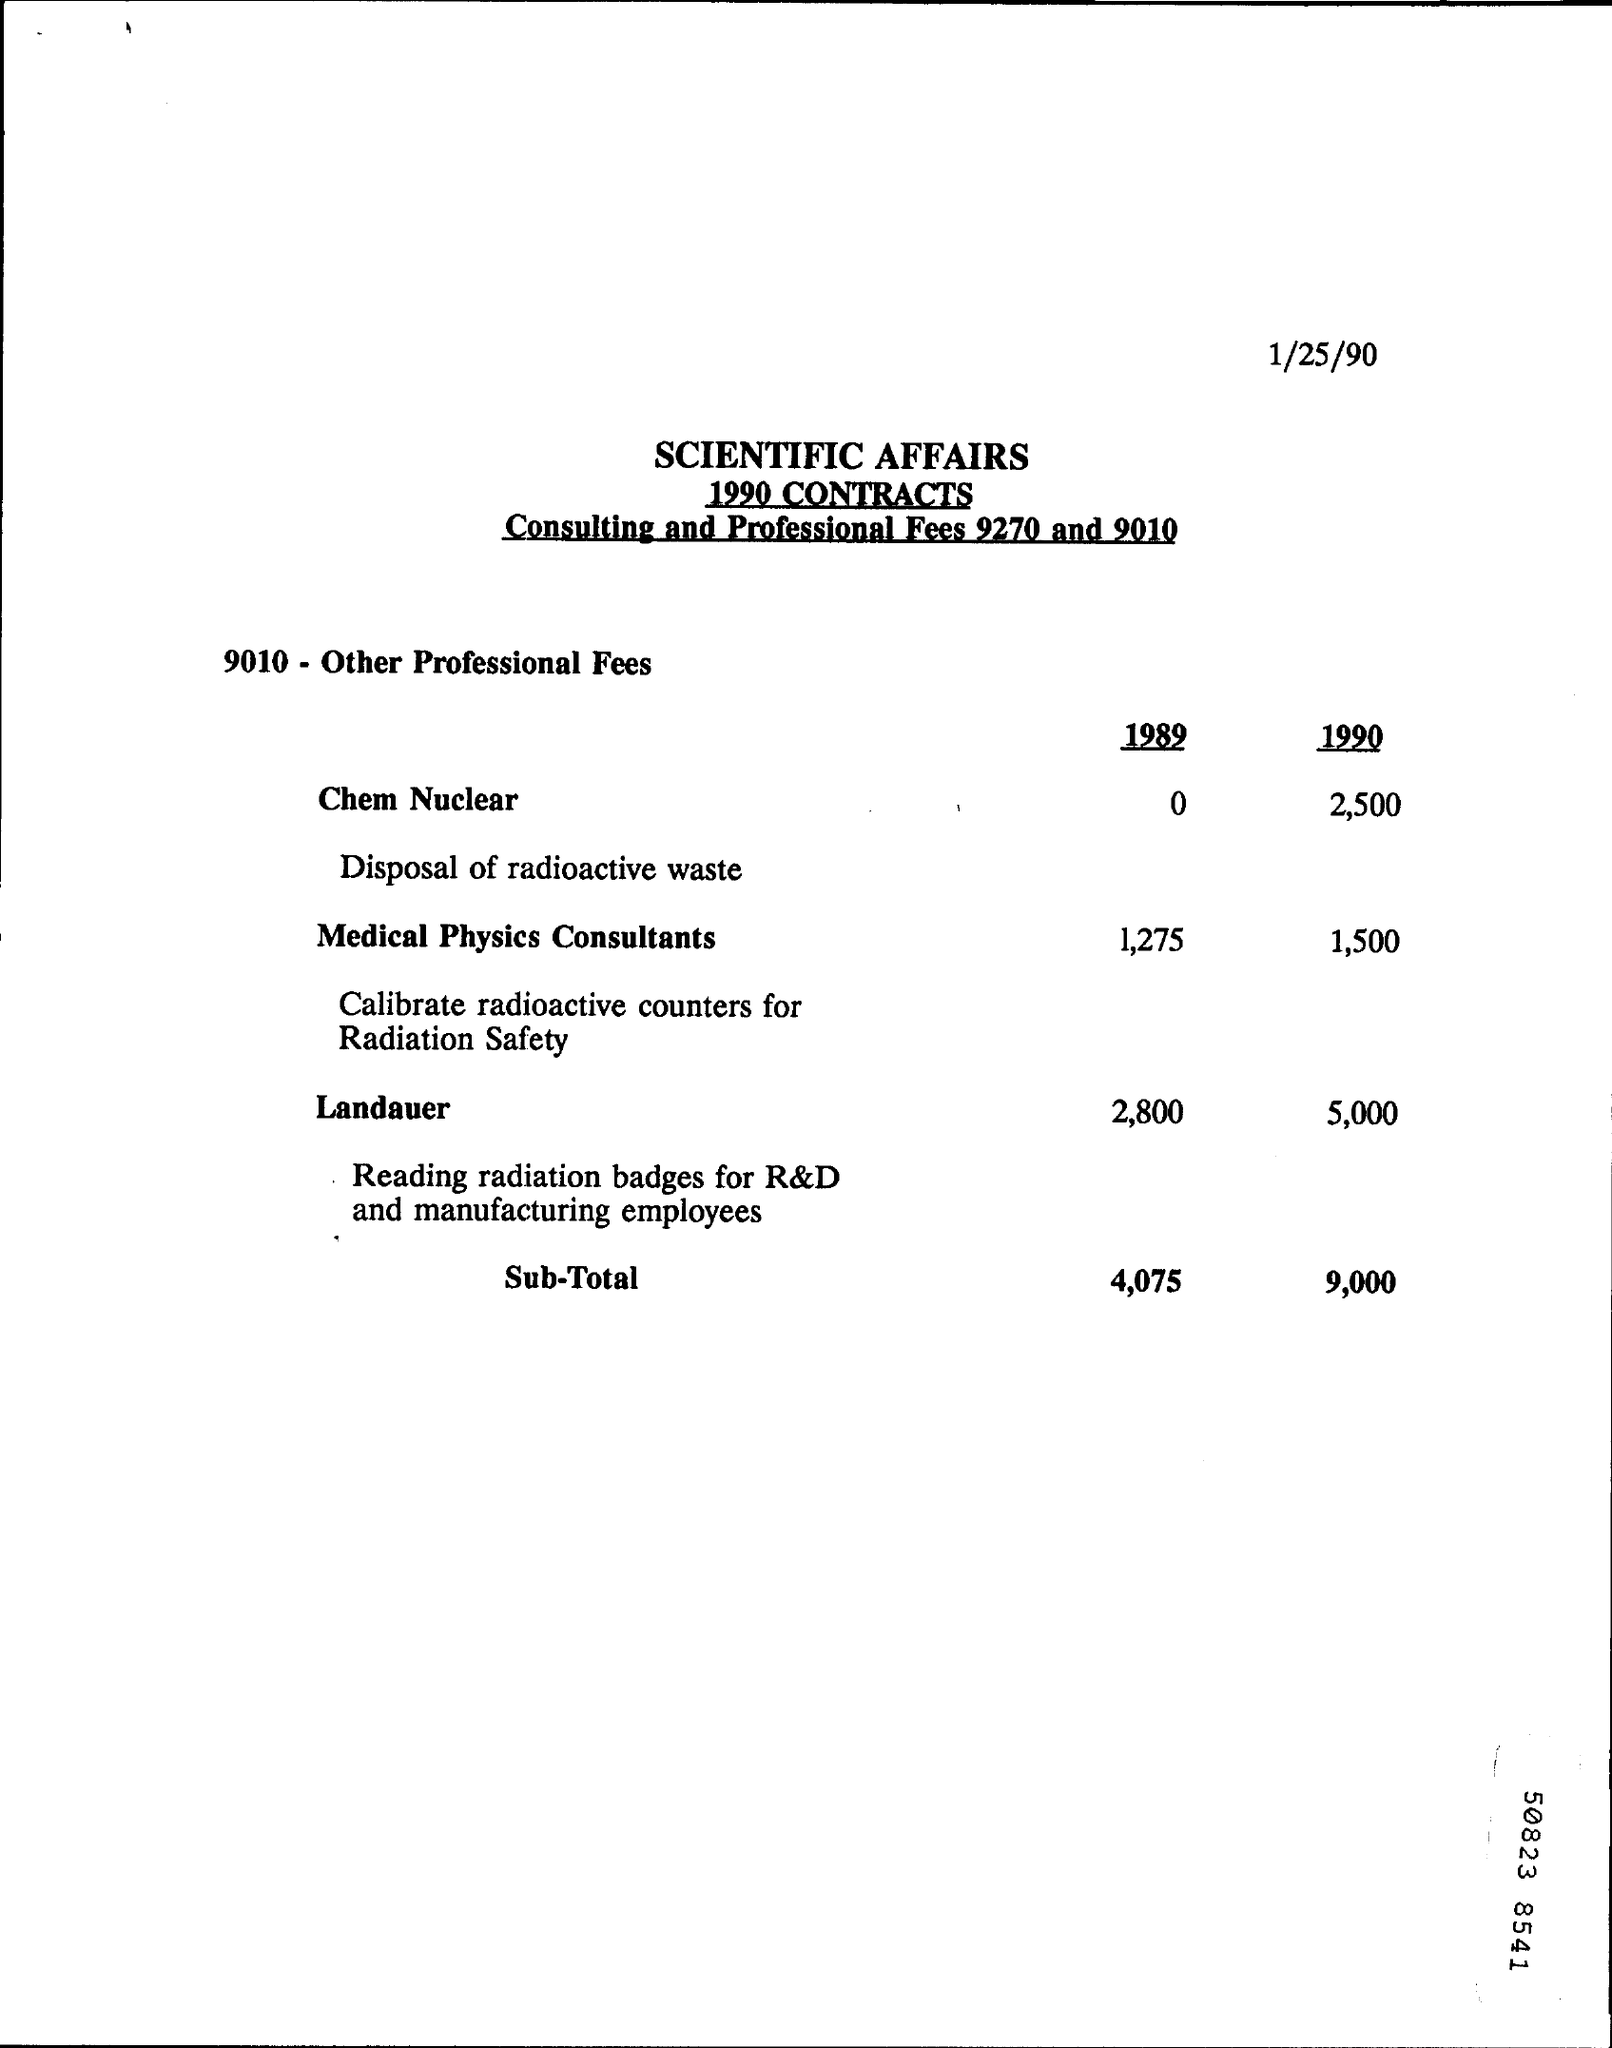Identify some key points in this picture. The Landauer fee, as of 1989, was approximately 2,800. In 1989, the sub-total was 4,075. In 1990, the Landauer fee was 5,000. In 1990, the fee for Medical Physics Consultants was 1,500. In 1990, the cost of a Chem Nuclear was approximately 2,500. 